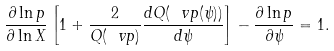<formula> <loc_0><loc_0><loc_500><loc_500>\frac { \partial \ln p } { \partial \ln X } \left [ 1 + \frac { 2 } { Q ( \ v p ) } \frac { { d } Q ( \ v p ( \psi ) ) } { { d } \psi } \right ] - \frac { \partial \ln p } { \partial \psi } = 1 .</formula> 